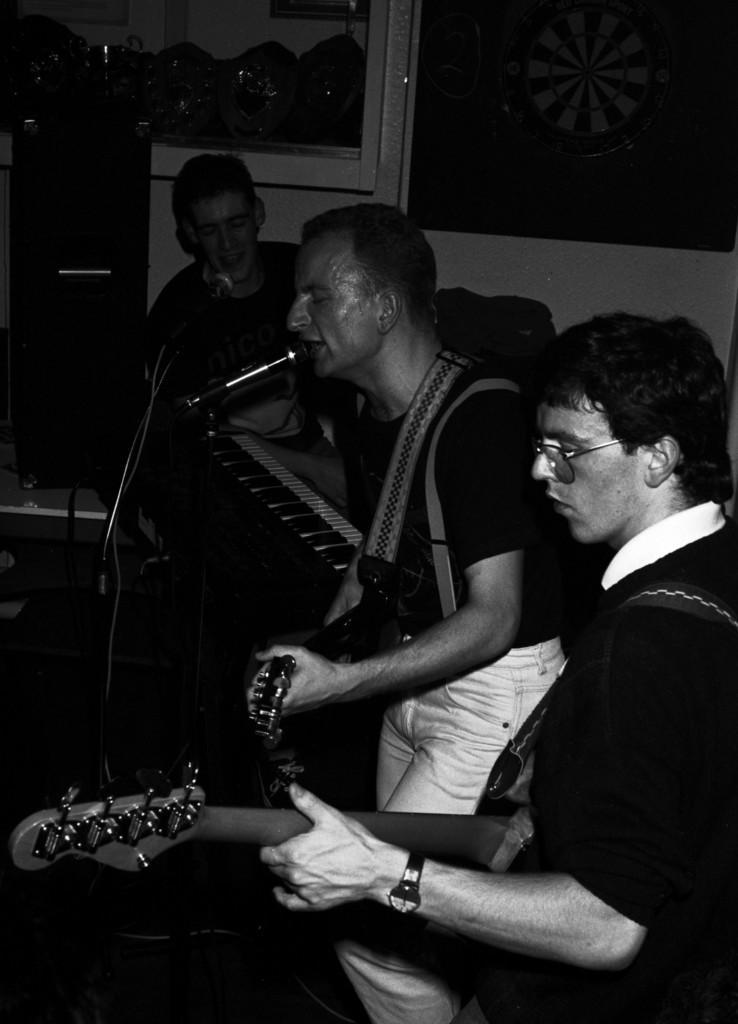Could you give a brief overview of what you see in this image? There are two people with black t-shirt is standing and playing guitar. The man in the middle is singing, in front of him there is a mic. And the men with another black t-shirt is sitting and playing a piano. In front of him there is a mic. 